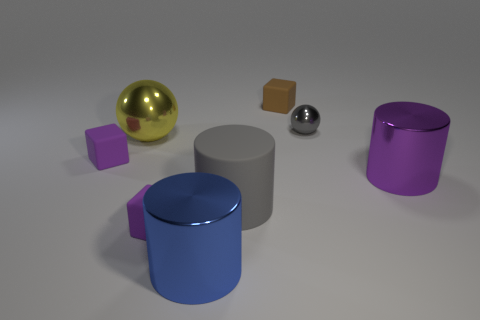Is the size of the purple matte cube that is in front of the large purple object the same as the purple matte cube that is behind the large purple shiny cylinder?
Your response must be concise. Yes. Is the number of purple metal cylinders less than the number of tiny red objects?
Your answer should be compact. No. What number of big cylinders are left of the big gray cylinder?
Offer a terse response. 1. What is the material of the yellow sphere?
Make the answer very short. Metal. Is the big metallic sphere the same color as the small metal object?
Give a very brief answer. No. Are there fewer large blue things behind the matte cylinder than yellow shiny things?
Offer a very short reply. Yes. What color is the large ball that is left of the purple cylinder?
Offer a very short reply. Yellow. What shape is the tiny shiny thing?
Make the answer very short. Sphere. There is a big shiny cylinder on the right side of the metal sphere to the right of the brown rubber thing; are there any large blue metallic objects that are in front of it?
Your answer should be compact. Yes. There is a small thing that is in front of the metallic cylinder on the right side of the tiny cube that is behind the yellow metal thing; what color is it?
Give a very brief answer. Purple. 